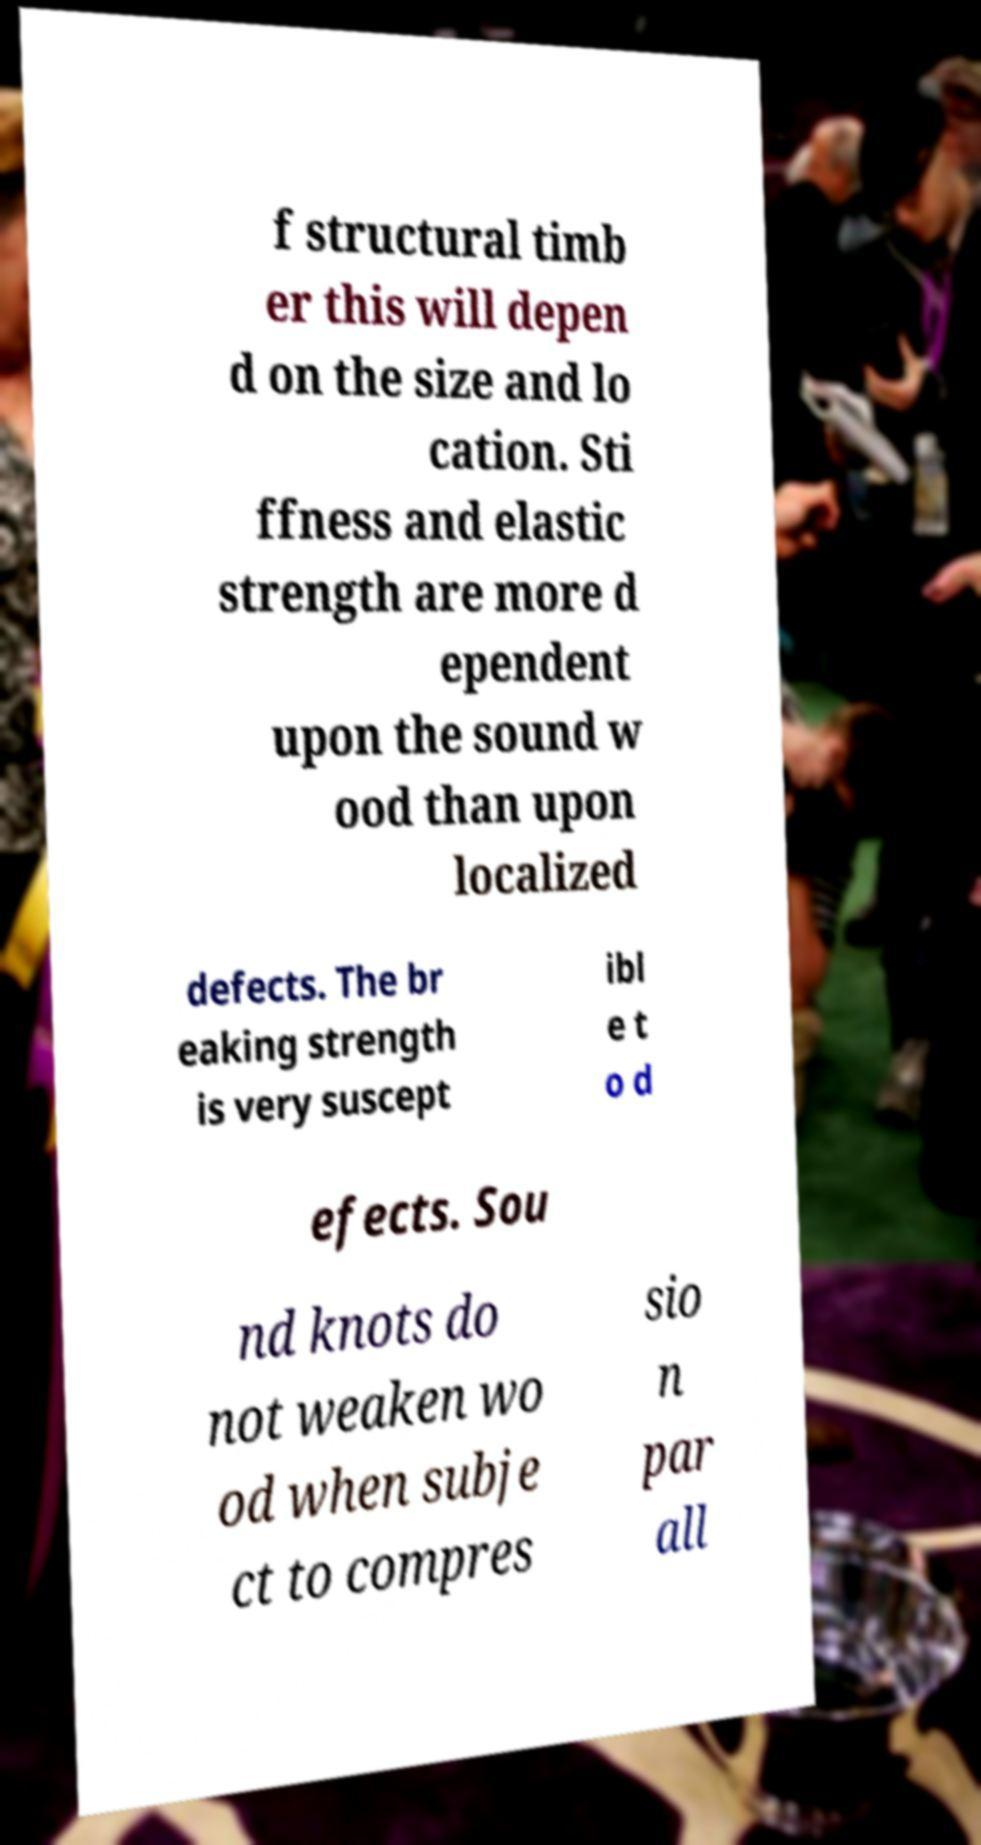I need the written content from this picture converted into text. Can you do that? f structural timb er this will depen d on the size and lo cation. Sti ffness and elastic strength are more d ependent upon the sound w ood than upon localized defects. The br eaking strength is very suscept ibl e t o d efects. Sou nd knots do not weaken wo od when subje ct to compres sio n par all 